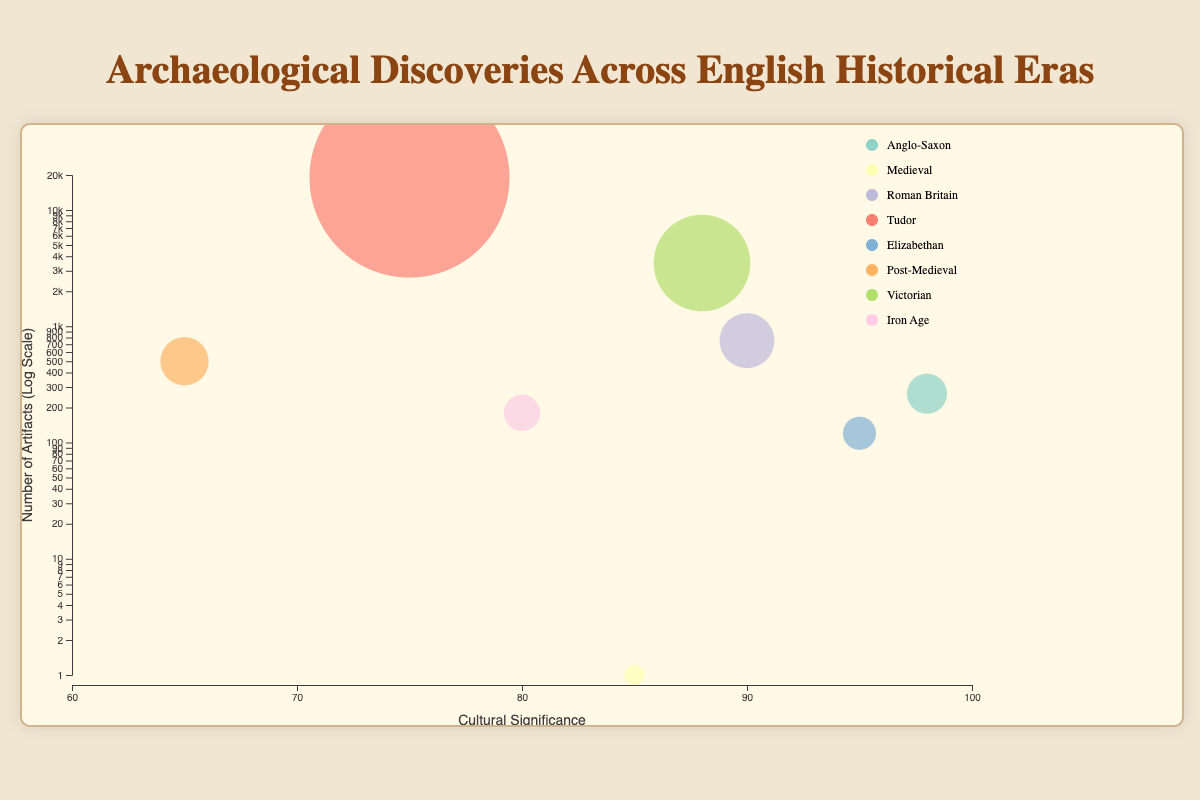What is the title of the bubble chart? The title of the bubble chart is prominently displayed at the top center of the chart.
Answer: Archaeological Discoveries Across English Historical Eras Which era has the highest cultural significance? The era with the highest cultural significance can be identified by finding the bubble positioned furthest to the right on the x-axis.
Answer: Anglo-Saxon (Sutton Hoo Treasure) Which discovery has the largest number of artifacts found? The discovery with the largest number of artifacts found is represented by the biggest bubble on the chart.
Answer: Mary Rose Wreck (Tudor) How many eras have discoveries with a cultural significance greater than 90? Count the number of bubbles positioned above the 90 mark on the x-axis.
Answer: Three (Anglo-Saxon, Roman Britain, Elizabethan) What is the relative position of the Middleham Jewel discovery on the y-axis? The Middleham Jewel discovery can be located by its era (Medieval) and then by observing its position on the y-axis, which uses a log scale, to represent the number of artifacts.
Answer: Very low, around 1 artifact Which discovery represents the Victorian era and how many artifacts were found there? Identify the bubble colored according to the Victorian era and refer to the tooltip or legend for details.
Answer: Staffordshire Hoard, 3500 artifacts Compare the cultural significance and number of artifacts found between the Sutton Hoo Treasure and Vindolanda Tablets. Identify and compare the positions and sizes of the two bubbles. Sutton Hoo is at a cultural significance of 98 with 263 artifacts, and Vindolanda Tablets are at 90 with 752 artifacts.
Answer: Sutton Hoo has higher cultural significance but fewer artifacts What is the main trend seen between cultural significance and number of artifacts? Observe if there is a general pattern in the positioning of bubbles across the x and y axes. While cultural significance does not directly correlate with the number of artifacts, higher significance seems less frequently associated with very high artifact numbers.
Answer: No clear trend Which discovery has a similar number of artifacts as the Snettisham Hoard but lower cultural significance? Look for a bubble with a similar position on the y-axis (artifacts) but a lower position on the x-axis (cultural significance).
Answer: London Shipwreck (Post-Medieval) What does the bubble chart indicate about the cultural significance of the discoveries from the Elizabethan and Tudor eras? Compare the positions of the Elizabethan and Tudor bubbles for their cultural significance values. The Elizabethan discovery (Shakespeare's Globe Site) has a higher cultural significance (95) compared to the Tudor discovery (Mary Rose Wreck) at 75.
Answer: Elizabethan has higher cultural significance than Tudor 